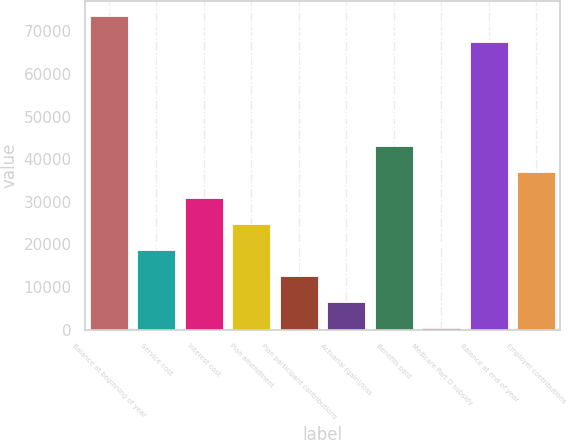Convert chart to OTSL. <chart><loc_0><loc_0><loc_500><loc_500><bar_chart><fcel>Balance at beginning of year<fcel>Service cost<fcel>Interest cost<fcel>Plan amendment<fcel>Plan participant contributions<fcel>Actuarial (gain)/loss<fcel>Benefits paid<fcel>Medicare Part D subsidy<fcel>Balance at end of year<fcel>Employer contributions<nl><fcel>73485.6<fcel>18699.9<fcel>30874.5<fcel>24787.2<fcel>12612.6<fcel>6525.3<fcel>43049.1<fcel>438<fcel>67398.3<fcel>36961.8<nl></chart> 